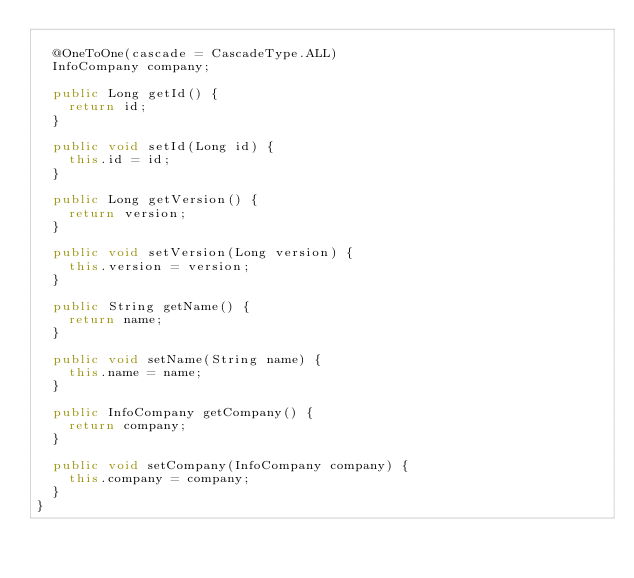<code> <loc_0><loc_0><loc_500><loc_500><_Java_>
  @OneToOne(cascade = CascadeType.ALL)
  InfoCompany company;

  public Long getId() {
    return id;
  }

  public void setId(Long id) {
    this.id = id;
  }

  public Long getVersion() {
    return version;
  }

  public void setVersion(Long version) {
    this.version = version;
  }

  public String getName() {
    return name;
  }

  public void setName(String name) {
    this.name = name;
  }

  public InfoCompany getCompany() {
    return company;
  }

  public void setCompany(InfoCompany company) {
    this.company = company;
  }
}
</code> 